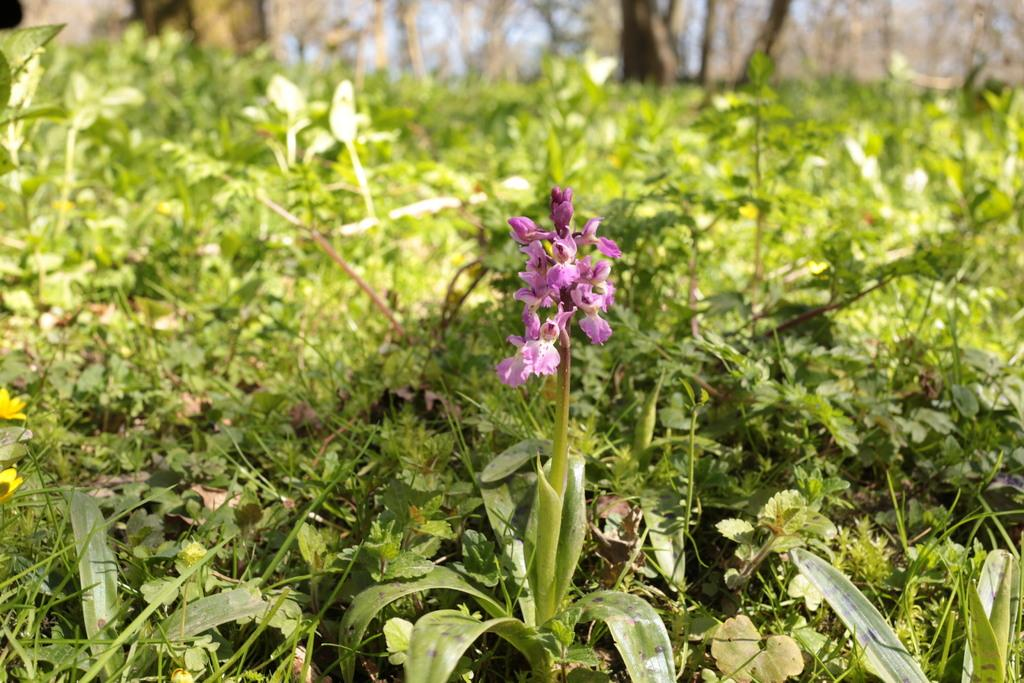What type of vegetation is predominant in the image? There is a lot of grass in the image. Can you describe any specific plants in the image? There is a plant with beautiful flowers in the image. What type of bomb is hidden in the grass in the image? There is no bomb present in the image; it only features grass and a plant with beautiful flowers. How many flies can be seen buzzing around the flowers in the image? There are no flies present in the image; it only features grass and a plant with beautiful flowers. 